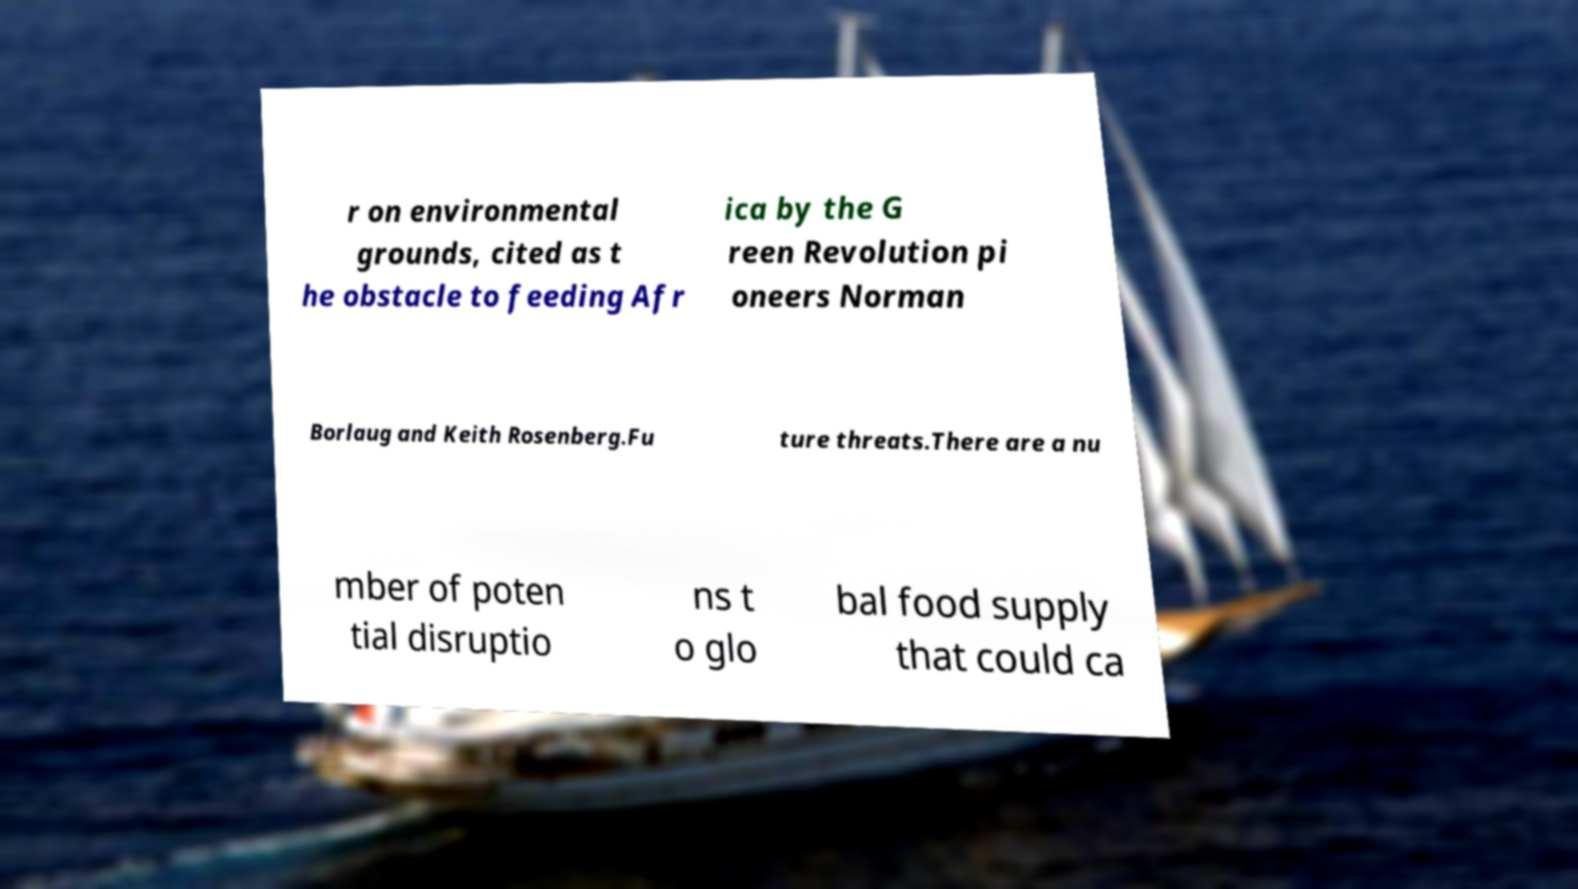There's text embedded in this image that I need extracted. Can you transcribe it verbatim? r on environmental grounds, cited as t he obstacle to feeding Afr ica by the G reen Revolution pi oneers Norman Borlaug and Keith Rosenberg.Fu ture threats.There are a nu mber of poten tial disruptio ns t o glo bal food supply that could ca 